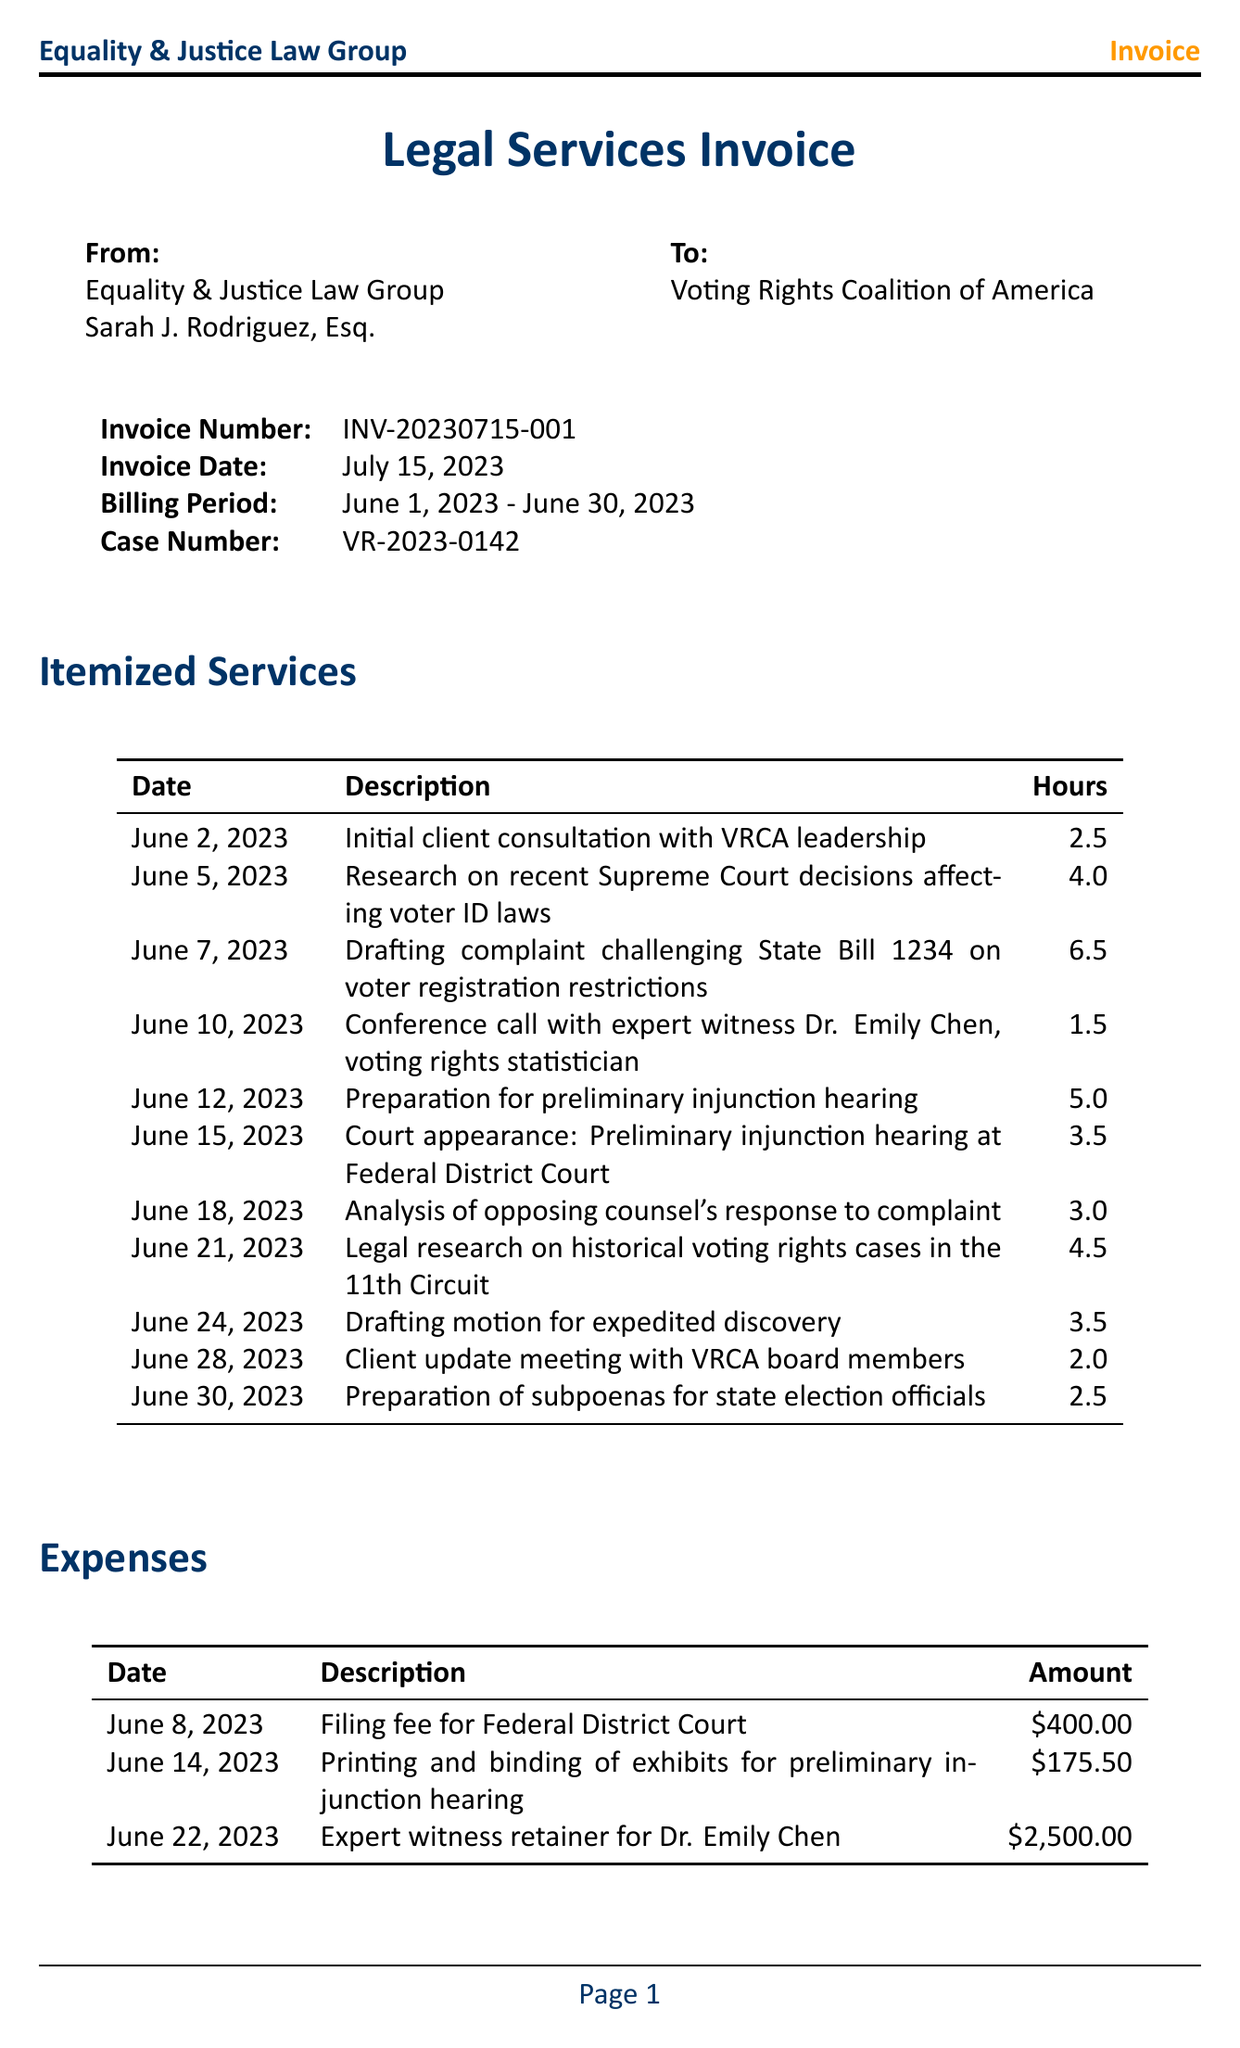What is the name of the law firm? The law firm's name is listed at the top of the document.
Answer: Equality & Justice Law Group What is the hourly rate charged by the attorney? The hourly rate is specified in the summary section of the invoice.
Answer: 350 What is the total number of hours billed? The total hours are summarized at the end of the services section.
Answer: 38.5 When was the invoice date? The invoice date is clearly stated in the header of the document.
Answer: July 15, 2023 What is the case number for this lawsuit? The case number is provided in the header of the invoice.
Answer: VR-2023-0142 What is the amount charged for the expert witness retainer? The expense for the expert witness retainer is listed in the expenses section.
Answer: 2500.00 How many hours were spent on drafting the complaint? The hours for drafting the complaint are itemized under the services section.
Answer: 6.5 What is the grand total amount due? The grand total is found in the summary section of the invoice.
Answer: 16550.50 What are the payment terms for this invoice? The payment terms are stated towards the end of the document.
Answer: Due within 30 days of invoice date 